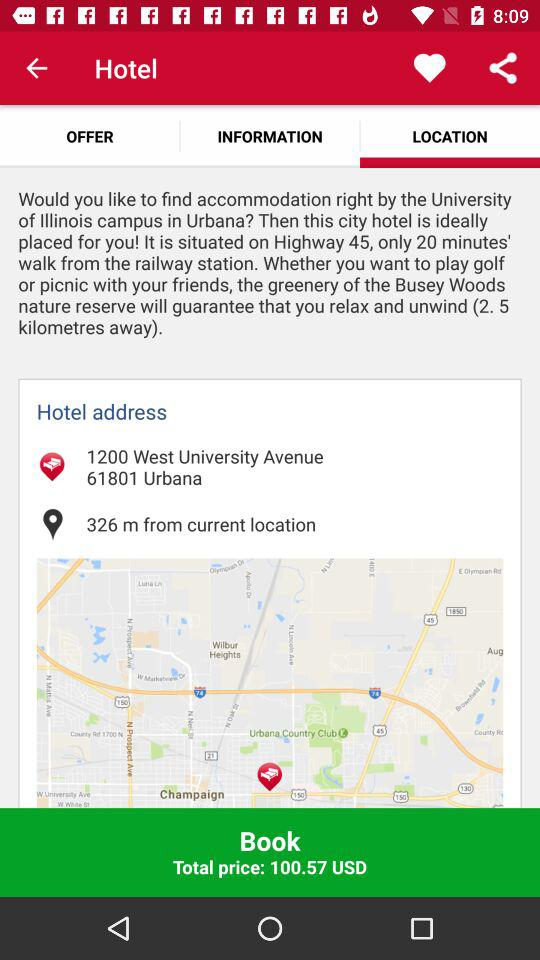How far is the hotel from the user's current location?
Answer the question using a single word or phrase. 326 m 